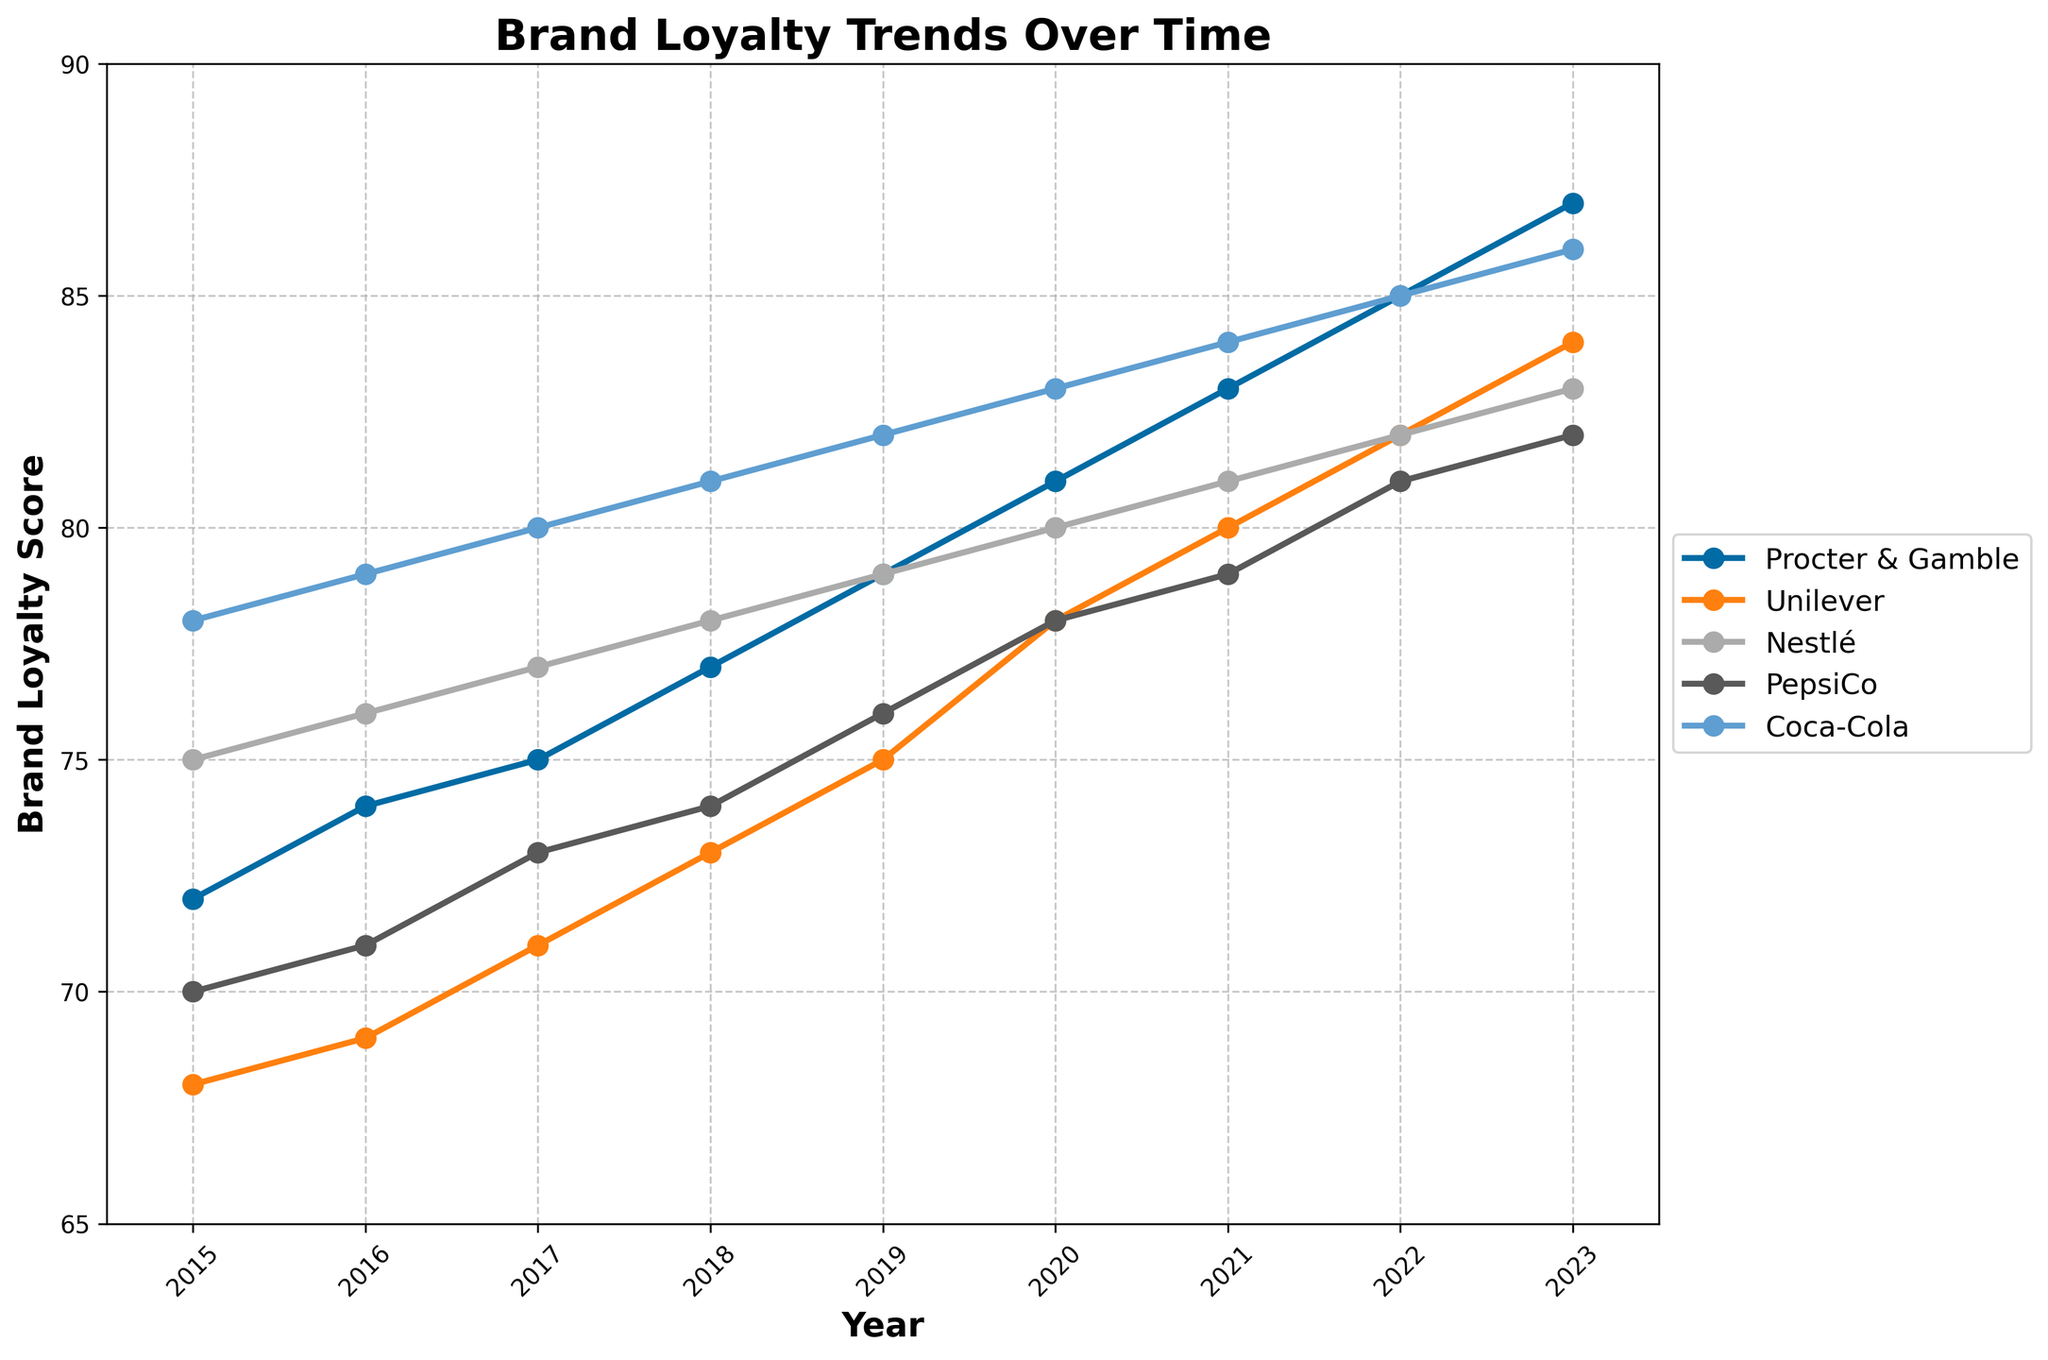Which company had the highest brand loyalty score in 2023? To find the company with the highest score in 2023, look at the data points for each company in that year. Coca-Cola has a score of 86, which is the highest among all companies.
Answer: Coca-Cola Which company showed the largest increase in brand loyalty score between 2015 and 2023? Calculate the difference in brand loyalty scores between 2015 and 2023 for each company. P&G increased by 15 (87-72), Unilever by 16 (84-68), Nestlé by 8 (83-75), PepsiCo by 12 (82-70), and Coca-Cola by 8 (86-78). Unilever had the largest increase (16 points).
Answer: Unilever What was the average brand loyalty score for PepsiCo from 2015 to 2023? Add up the scores for PepsiCo from 2015 to 2023 (70 + 71 + 73 + 74 + 76 + 78 + 79 + 81 + 82) = 684. Then, divide by the number of years (9). The average score is 684/9 = 76.
Answer: 76 In which year did Procter & Gamble achieve a higher brand loyalty score than Nestlé? Compare the scores of Procter & Gamble and Nestlé in each year. In 2023, P&G scored 87 and Nestlé scored 83. P&G's score first exceeded Nestlé's in 2023.
Answer: 2023 Which company started with the highest brand loyalty score in 2015 and is it still the highest in 2023? In 2015, Coca-Cola had the highest score at 78. In 2023, it still has the highest score at 86, although other companies’ scores increased as well.
Answer: Coca-Cola What is the total increase in brand loyalty score for Nestlé from 2015 to 2023? Subtract the 2015 score from the 2023 score for Nestlé: 83 - 75 = 8.
Answer: 8 Which year had the smallest difference between the highest and lowest brand loyalty scores among the companies? Review the score differences for each year to find the smallest. In 2023, the highest score is 86 (Coca-Cola) and the lowest is 82 (PepsiCo), so the difference is 4. No other year has a smaller difference than 4.
Answer: 2023 Between 2019 and 2022, which company had the most consistent brand loyalty score increase? Calculate the yearly score increases for each company between 2019 and 2022. Procter & Gamble increases were 2 each year (79 to 81 to 83 to 85). Other companies had more variable year-to-year changes.
Answer: Procter & Gamble 